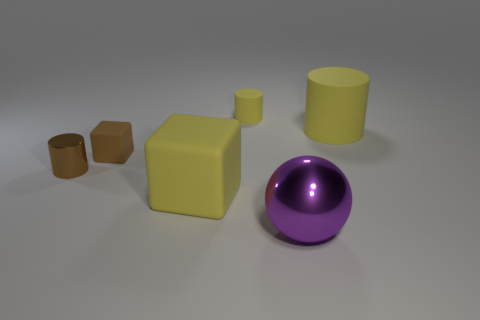Add 4 matte cubes. How many objects exist? 10 Subtract all blocks. How many objects are left? 4 Subtract all green matte spheres. Subtract all small yellow matte cylinders. How many objects are left? 5 Add 5 large purple things. How many large purple things are left? 6 Add 1 tiny matte blocks. How many tiny matte blocks exist? 2 Subtract 1 brown cubes. How many objects are left? 5 